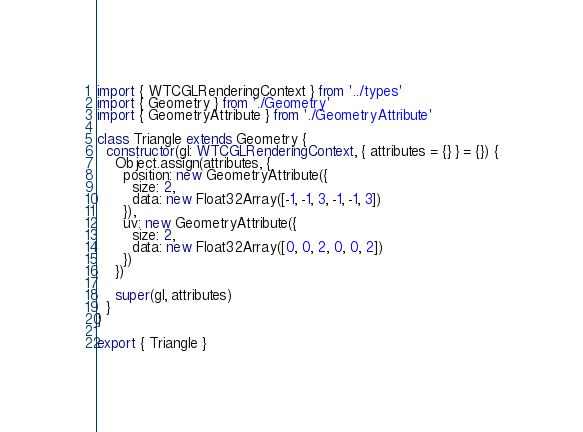<code> <loc_0><loc_0><loc_500><loc_500><_TypeScript_>import { WTCGLRenderingContext } from '../types'
import { Geometry } from './Geometry'
import { GeometryAttribute } from './GeometryAttribute'

class Triangle extends Geometry {
  constructor(gl: WTCGLRenderingContext, { attributes = {} } = {}) {
    Object.assign(attributes, {
      position: new GeometryAttribute({
        size: 2,
        data: new Float32Array([-1, -1, 3, -1, -1, 3])
      }),
      uv: new GeometryAttribute({
        size: 2,
        data: new Float32Array([0, 0, 2, 0, 0, 2])
      })
    })

    super(gl, attributes)
  }
}

export { Triangle }
</code> 